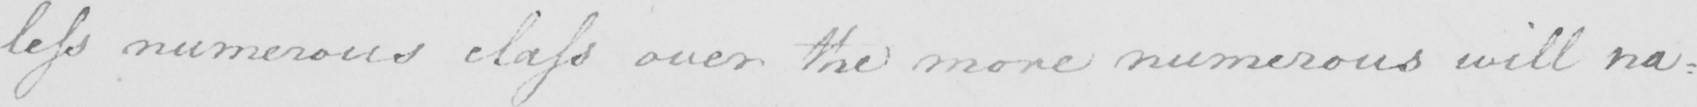What is written in this line of handwriting? less numerous class over the more numerous will na : 